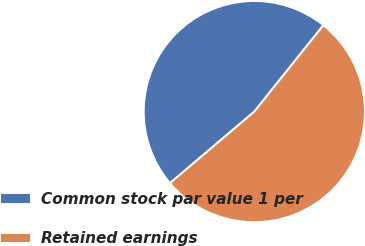Convert chart. <chart><loc_0><loc_0><loc_500><loc_500><pie_chart><fcel>Common stock par value 1 per<fcel>Retained earnings<nl><fcel>46.93%<fcel>53.07%<nl></chart> 